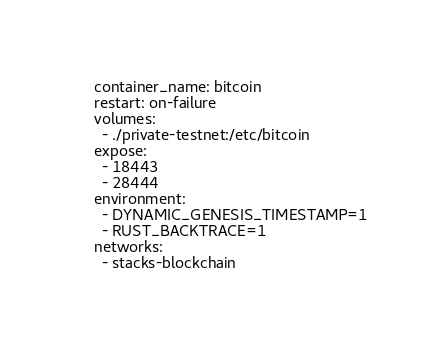<code> <loc_0><loc_0><loc_500><loc_500><_YAML_>    container_name: bitcoin
    restart: on-failure
    volumes:
      - ./private-testnet:/etc/bitcoin
    expose:
      - 18443
      - 28444
    environment:
      - DYNAMIC_GENESIS_TIMESTAMP=1
      - RUST_BACKTRACE=1
    networks:
      - stacks-blockchain
</code> 